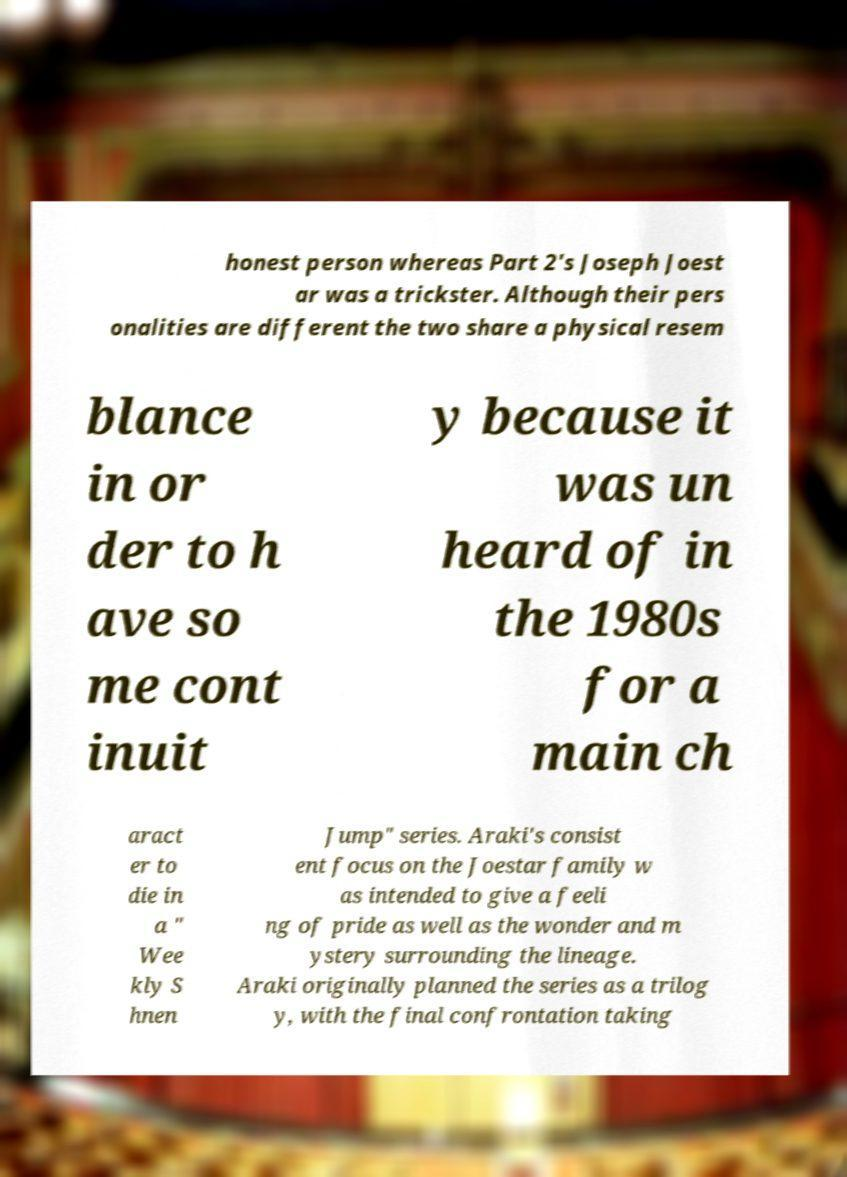Can you accurately transcribe the text from the provided image for me? honest person whereas Part 2's Joseph Joest ar was a trickster. Although their pers onalities are different the two share a physical resem blance in or der to h ave so me cont inuit y because it was un heard of in the 1980s for a main ch aract er to die in a " Wee kly S hnen Jump" series. Araki's consist ent focus on the Joestar family w as intended to give a feeli ng of pride as well as the wonder and m ystery surrounding the lineage. Araki originally planned the series as a trilog y, with the final confrontation taking 